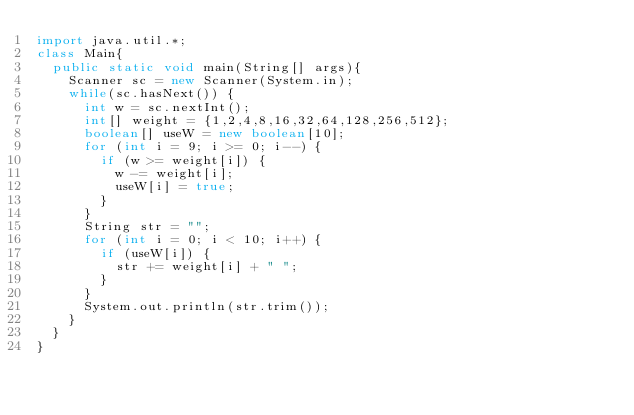<code> <loc_0><loc_0><loc_500><loc_500><_Java_>import java.util.*;
class Main{
  public static void main(String[] args){
    Scanner sc = new Scanner(System.in);
    while(sc.hasNext()) {
      int w = sc.nextInt();
      int[] weight = {1,2,4,8,16,32,64,128,256,512};
      boolean[] useW = new boolean[10];
      for (int i = 9; i >= 0; i--) {
        if (w >= weight[i]) {
          w -= weight[i];
          useW[i] = true;
        }
      }
      String str = "";
      for (int i = 0; i < 10; i++) {
        if (useW[i]) {
          str += weight[i] + " ";
        }
      }
      System.out.println(str.trim());
    }
  }
}</code> 